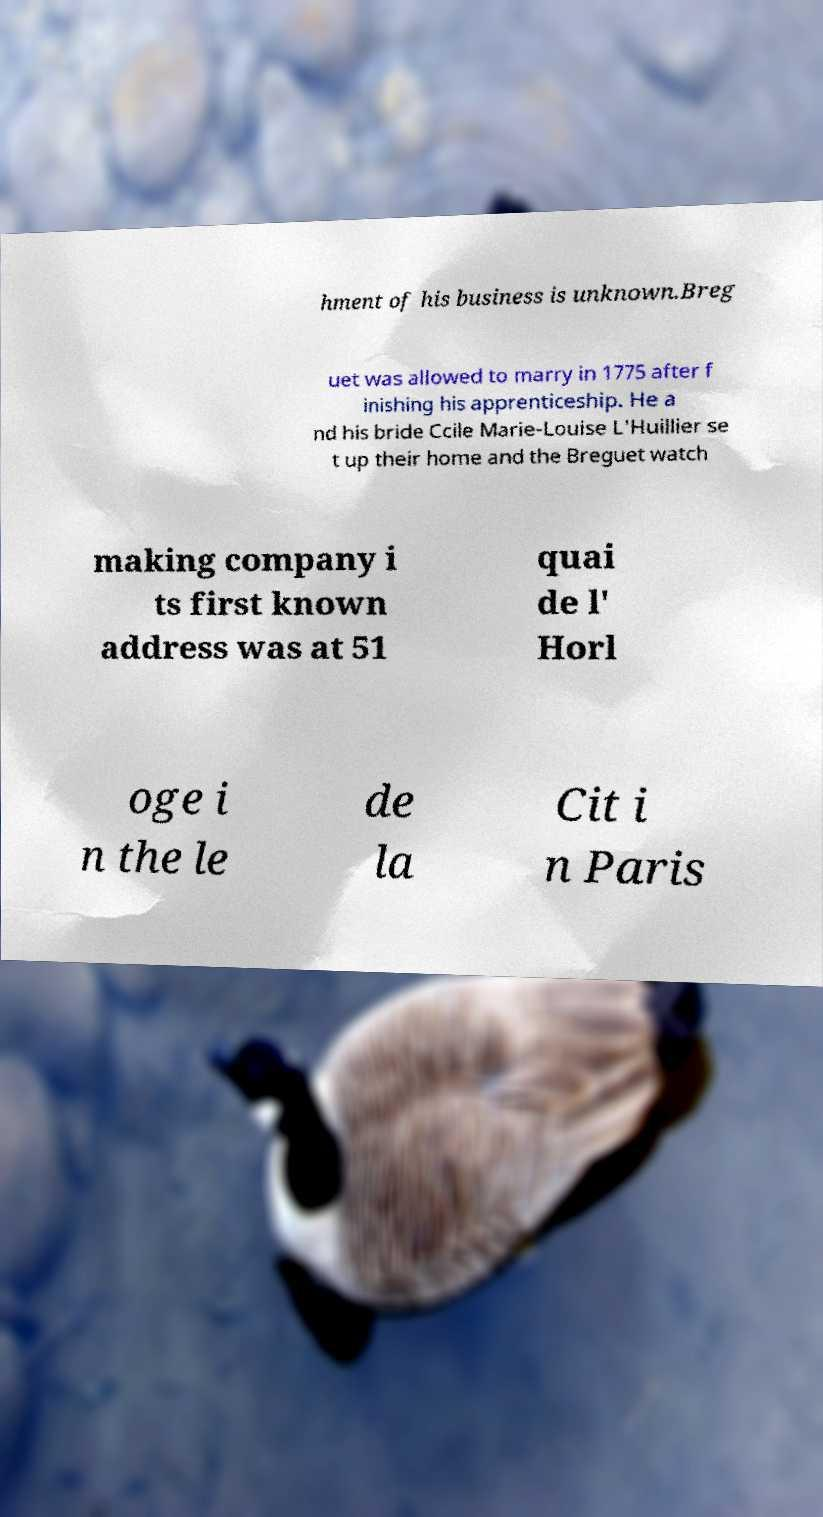There's text embedded in this image that I need extracted. Can you transcribe it verbatim? hment of his business is unknown.Breg uet was allowed to marry in 1775 after f inishing his apprenticeship. He a nd his bride Ccile Marie-Louise L'Huillier se t up their home and the Breguet watch making company i ts first known address was at 51 quai de l' Horl oge i n the le de la Cit i n Paris 